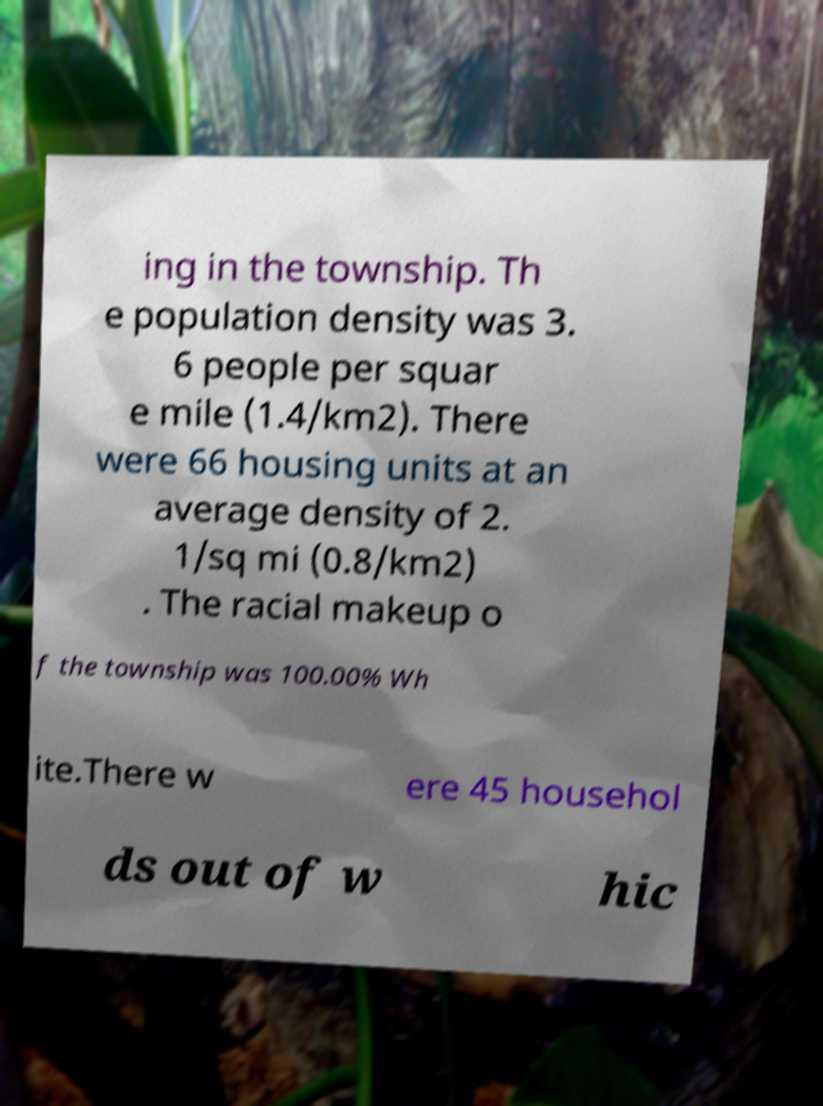Could you extract and type out the text from this image? ing in the township. Th e population density was 3. 6 people per squar e mile (1.4/km2). There were 66 housing units at an average density of 2. 1/sq mi (0.8/km2) . The racial makeup o f the township was 100.00% Wh ite.There w ere 45 househol ds out of w hic 